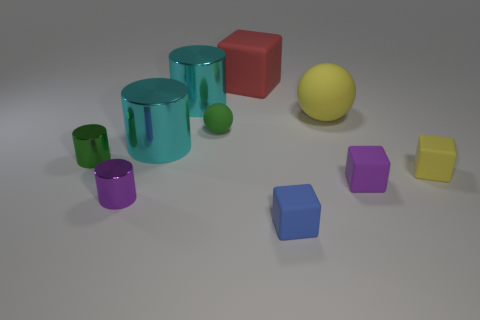Subtract all cylinders. How many objects are left? 6 Add 4 metal cylinders. How many metal cylinders exist? 8 Subtract 0 blue cylinders. How many objects are left? 10 Subtract all big cylinders. Subtract all green objects. How many objects are left? 6 Add 2 blue matte things. How many blue matte things are left? 3 